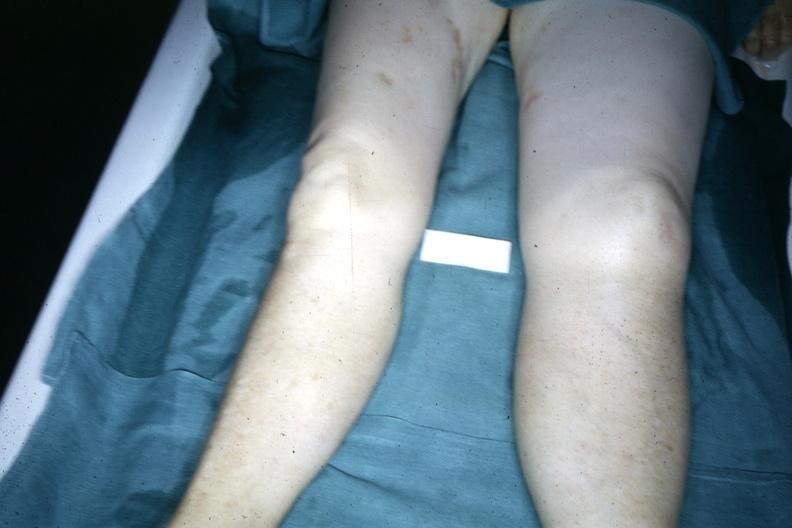what demonstrated with one about twice the size of the other due to malignant lymphoma involving lymphatic drainage?
Answer the question using a single word or phrase. Both legs 